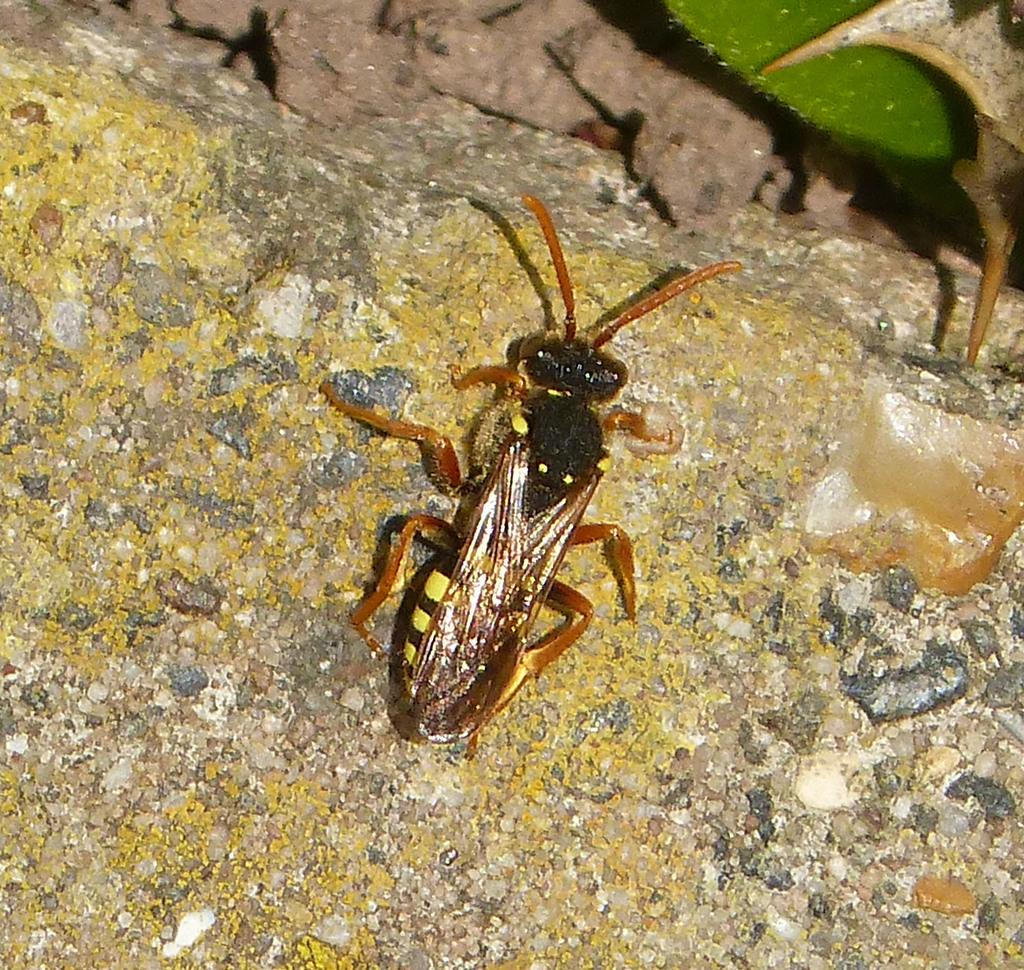What type of creature can be seen in the image? There is an insect in the image. What is located at the right top of the image? There is a leaf at the right top of the image. What type of trade is being conducted in the image? There is no indication of trade in the image; it features an insect and a leaf. What is the profit margin for the fowl in the image? There is no fowl present in the image, so it is not possible to determine a profit margin. 